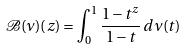Convert formula to latex. <formula><loc_0><loc_0><loc_500><loc_500>\mathcal { B } ( \nu ) ( z ) = \int _ { 0 } ^ { 1 } \frac { 1 - t ^ { z } } { 1 - t } \, d \nu ( t )</formula> 